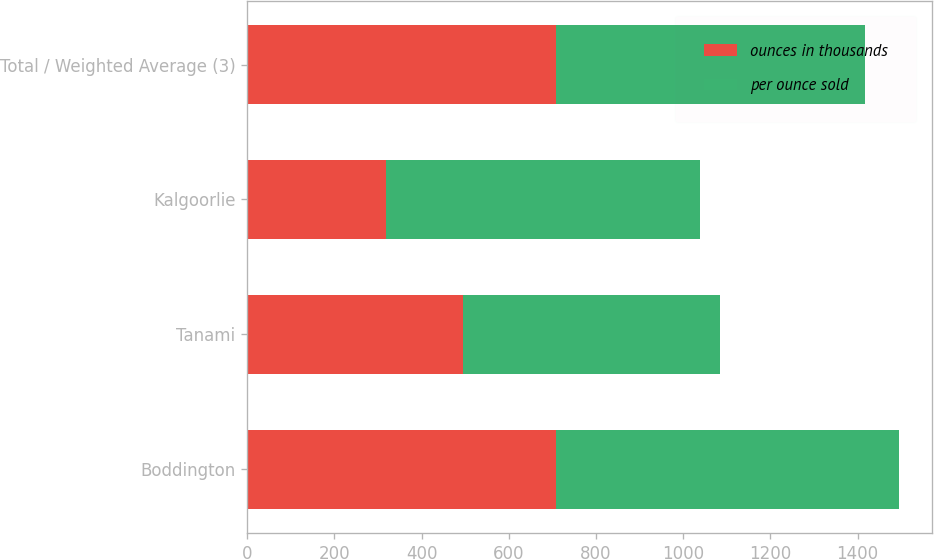Convert chart. <chart><loc_0><loc_0><loc_500><loc_500><stacked_bar_chart><ecel><fcel>Boddington<fcel>Tanami<fcel>Kalgoorlie<fcel>Total / Weighted Average (3)<nl><fcel>ounces in thousands<fcel>709<fcel>496<fcel>318<fcel>709<nl><fcel>per ounce sold<fcel>786<fcel>589<fcel>721<fcel>709<nl></chart> 